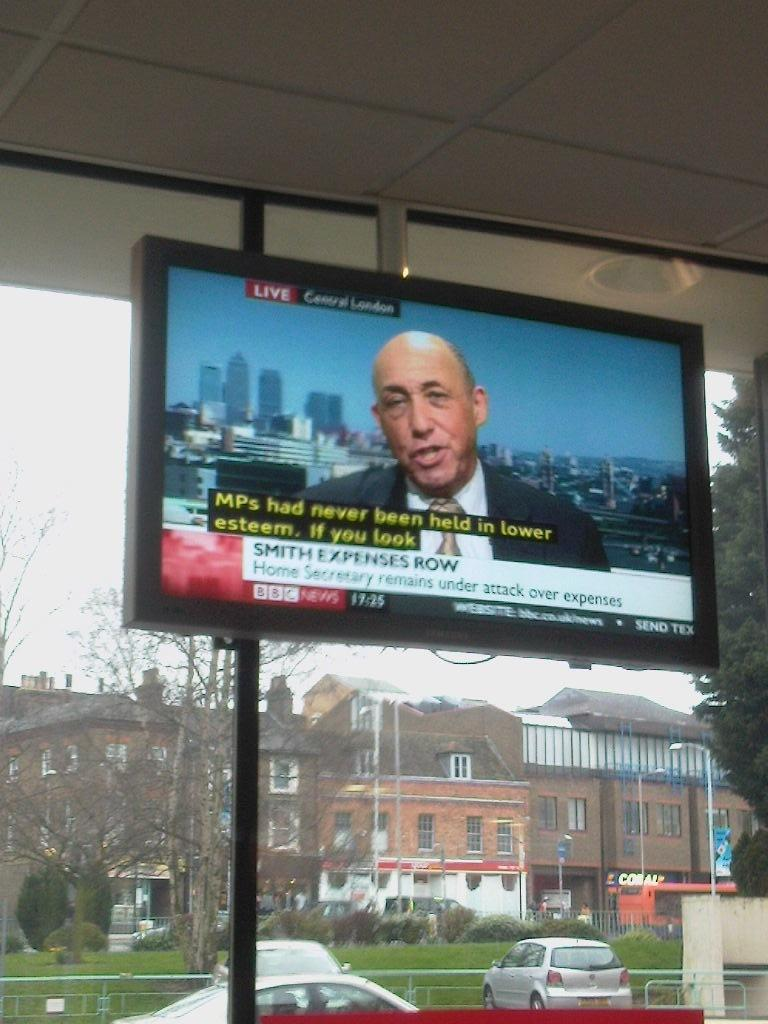<image>
Provide a brief description of the given image. A BBC news segment is airing on a television in front of a window. 